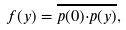Convert formula to latex. <formula><loc_0><loc_0><loc_500><loc_500>f ( y ) = \overline { { p } ( 0 ) { \cdot } { p } ( y ) } ,</formula> 